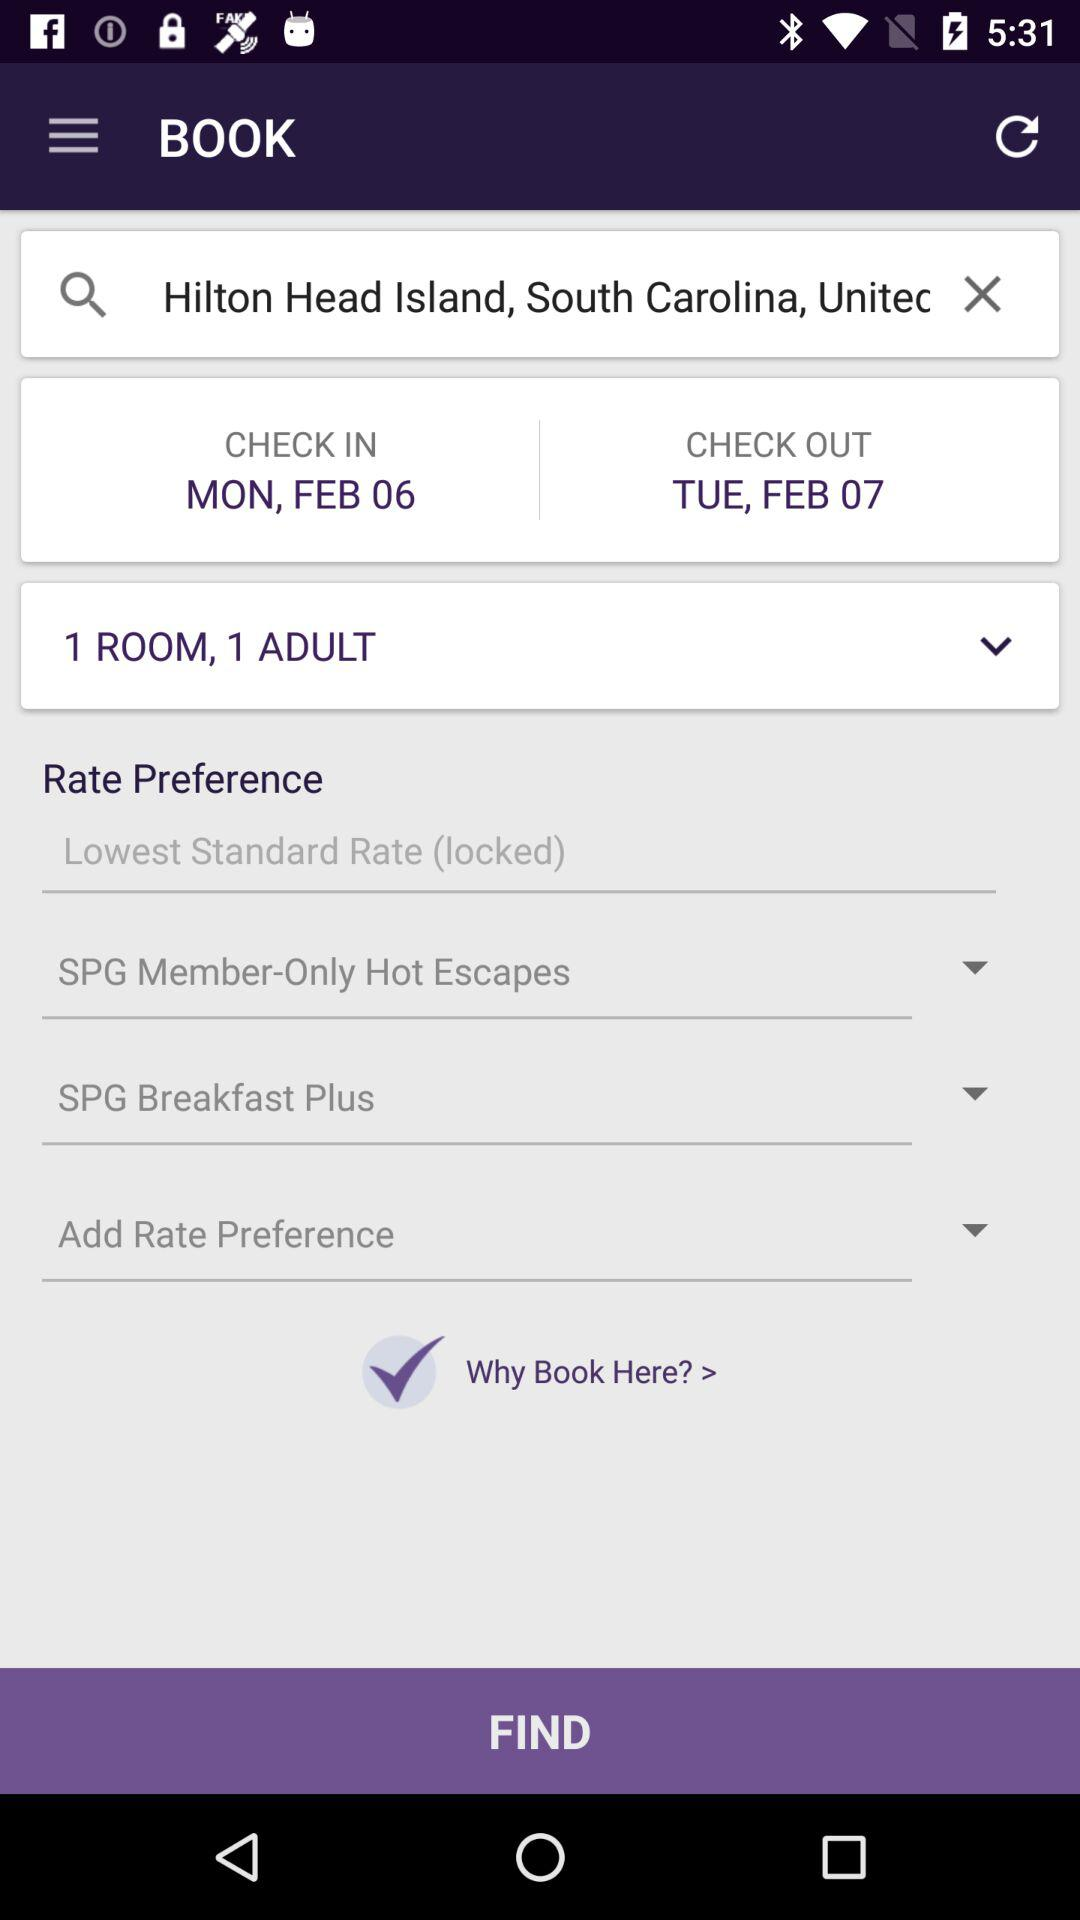What's the check-in date? The check-in date is Monday, February 6. 